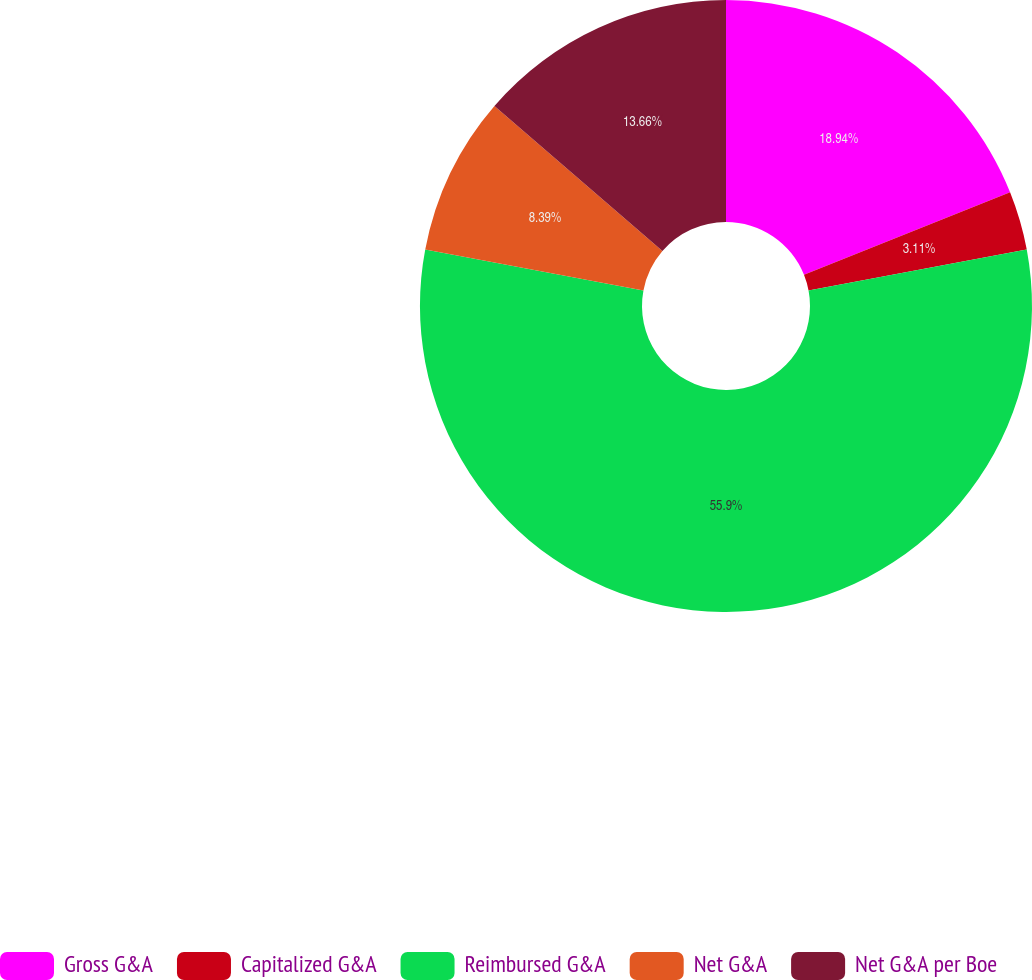<chart> <loc_0><loc_0><loc_500><loc_500><pie_chart><fcel>Gross G&A<fcel>Capitalized G&A<fcel>Reimbursed G&A<fcel>Net G&A<fcel>Net G&A per Boe<nl><fcel>18.94%<fcel>3.11%<fcel>55.9%<fcel>8.39%<fcel>13.66%<nl></chart> 